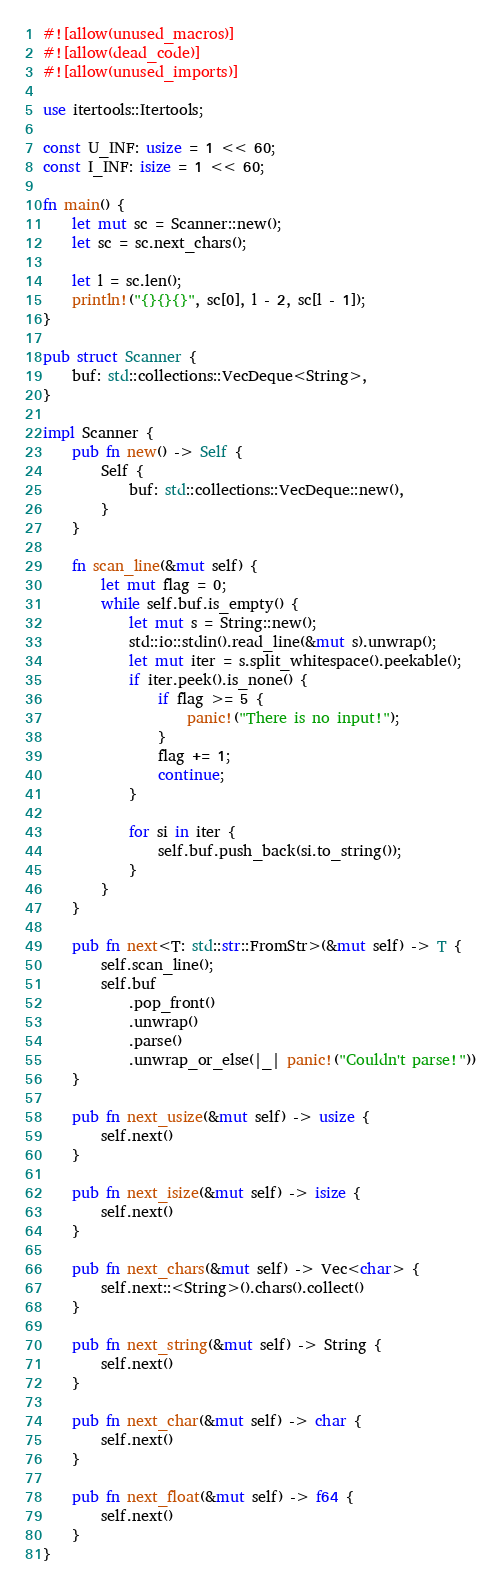<code> <loc_0><loc_0><loc_500><loc_500><_Rust_>#![allow(unused_macros)]
#![allow(dead_code)]
#![allow(unused_imports)]

use itertools::Itertools;

const U_INF: usize = 1 << 60;
const I_INF: isize = 1 << 60;

fn main() {
    let mut sc = Scanner::new();
    let sc = sc.next_chars();

    let l = sc.len();
    println!("{}{}{}", sc[0], l - 2, sc[l - 1]);
}

pub struct Scanner {
    buf: std::collections::VecDeque<String>,
}

impl Scanner {
    pub fn new() -> Self {
        Self {
            buf: std::collections::VecDeque::new(),
        }
    }

    fn scan_line(&mut self) {
        let mut flag = 0;
        while self.buf.is_empty() {
            let mut s = String::new();
            std::io::stdin().read_line(&mut s).unwrap();
            let mut iter = s.split_whitespace().peekable();
            if iter.peek().is_none() {
                if flag >= 5 {
                    panic!("There is no input!");
                }
                flag += 1;
                continue;
            }

            for si in iter {
                self.buf.push_back(si.to_string());
            }
        }
    }

    pub fn next<T: std::str::FromStr>(&mut self) -> T {
        self.scan_line();
        self.buf
            .pop_front()
            .unwrap()
            .parse()
            .unwrap_or_else(|_| panic!("Couldn't parse!"))
    }

    pub fn next_usize(&mut self) -> usize {
        self.next()
    }

    pub fn next_isize(&mut self) -> isize {
        self.next()
    }

    pub fn next_chars(&mut self) -> Vec<char> {
        self.next::<String>().chars().collect()
    }

    pub fn next_string(&mut self) -> String {
        self.next()
    }

    pub fn next_char(&mut self) -> char {
        self.next()
    }

    pub fn next_float(&mut self) -> f64 {
        self.next()
    }
}
</code> 